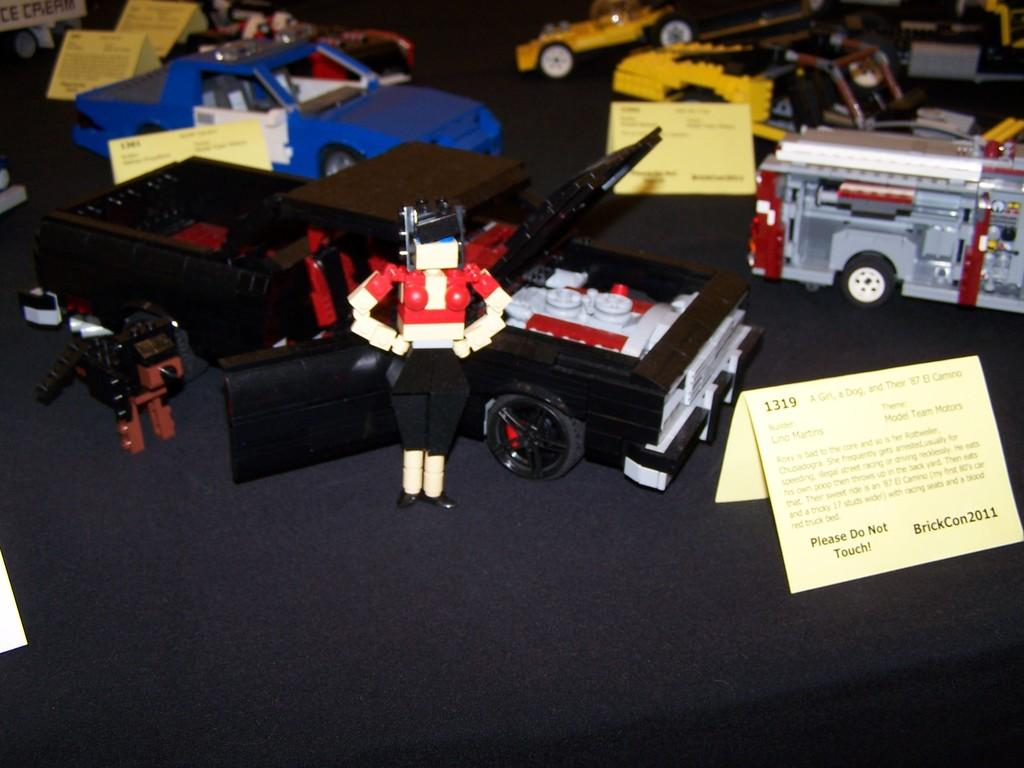<image>
Offer a succinct explanation of the picture presented. the word brickcon2011 is on the sign that is on a table 